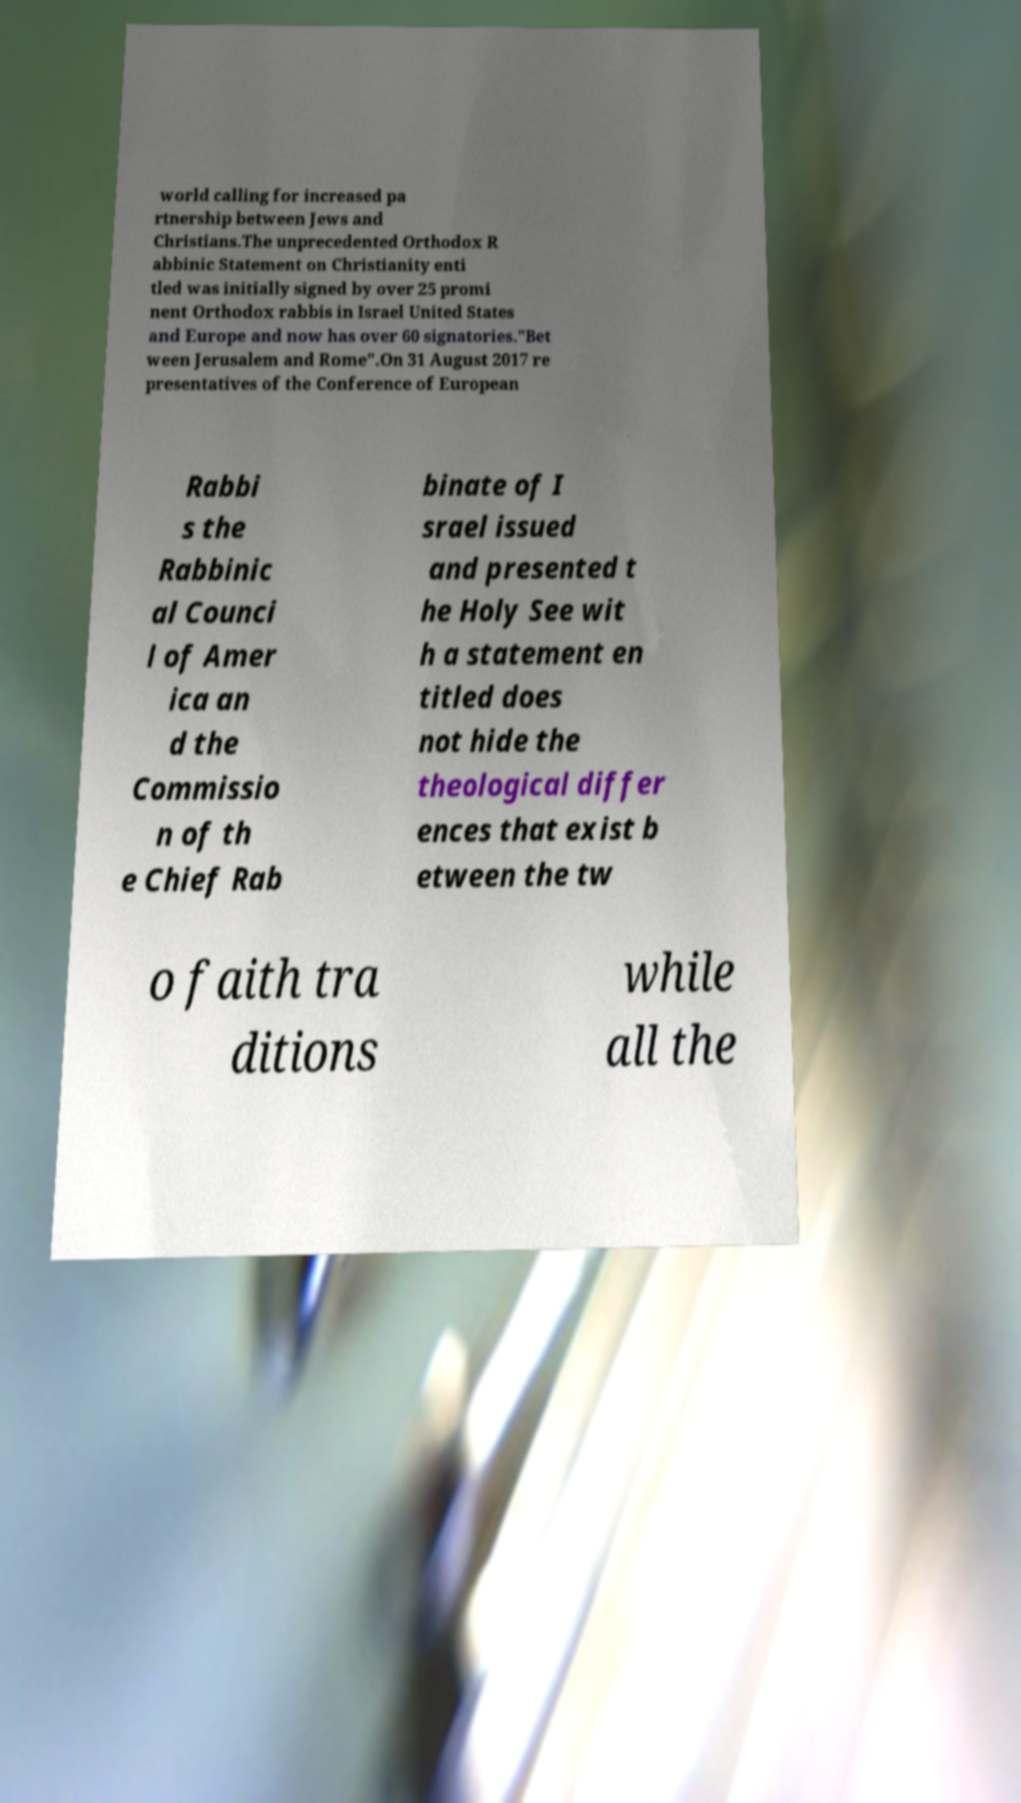Please identify and transcribe the text found in this image. world calling for increased pa rtnership between Jews and Christians.The unprecedented Orthodox R abbinic Statement on Christianity enti tled was initially signed by over 25 promi nent Orthodox rabbis in Israel United States and Europe and now has over 60 signatories."Bet ween Jerusalem and Rome".On 31 August 2017 re presentatives of the Conference of European Rabbi s the Rabbinic al Counci l of Amer ica an d the Commissio n of th e Chief Rab binate of I srael issued and presented t he Holy See wit h a statement en titled does not hide the theological differ ences that exist b etween the tw o faith tra ditions while all the 